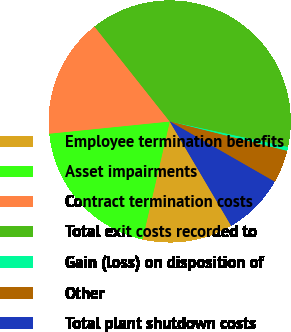<chart> <loc_0><loc_0><loc_500><loc_500><pie_chart><fcel>Employee termination benefits<fcel>Asset impairments<fcel>Contract termination costs<fcel>Total exit costs recorded to<fcel>Gain (loss) on disposition of<fcel>Other<fcel>Total plant shutdown costs<nl><fcel>12.08%<fcel>19.79%<fcel>15.94%<fcel>39.06%<fcel>0.52%<fcel>4.38%<fcel>8.23%<nl></chart> 